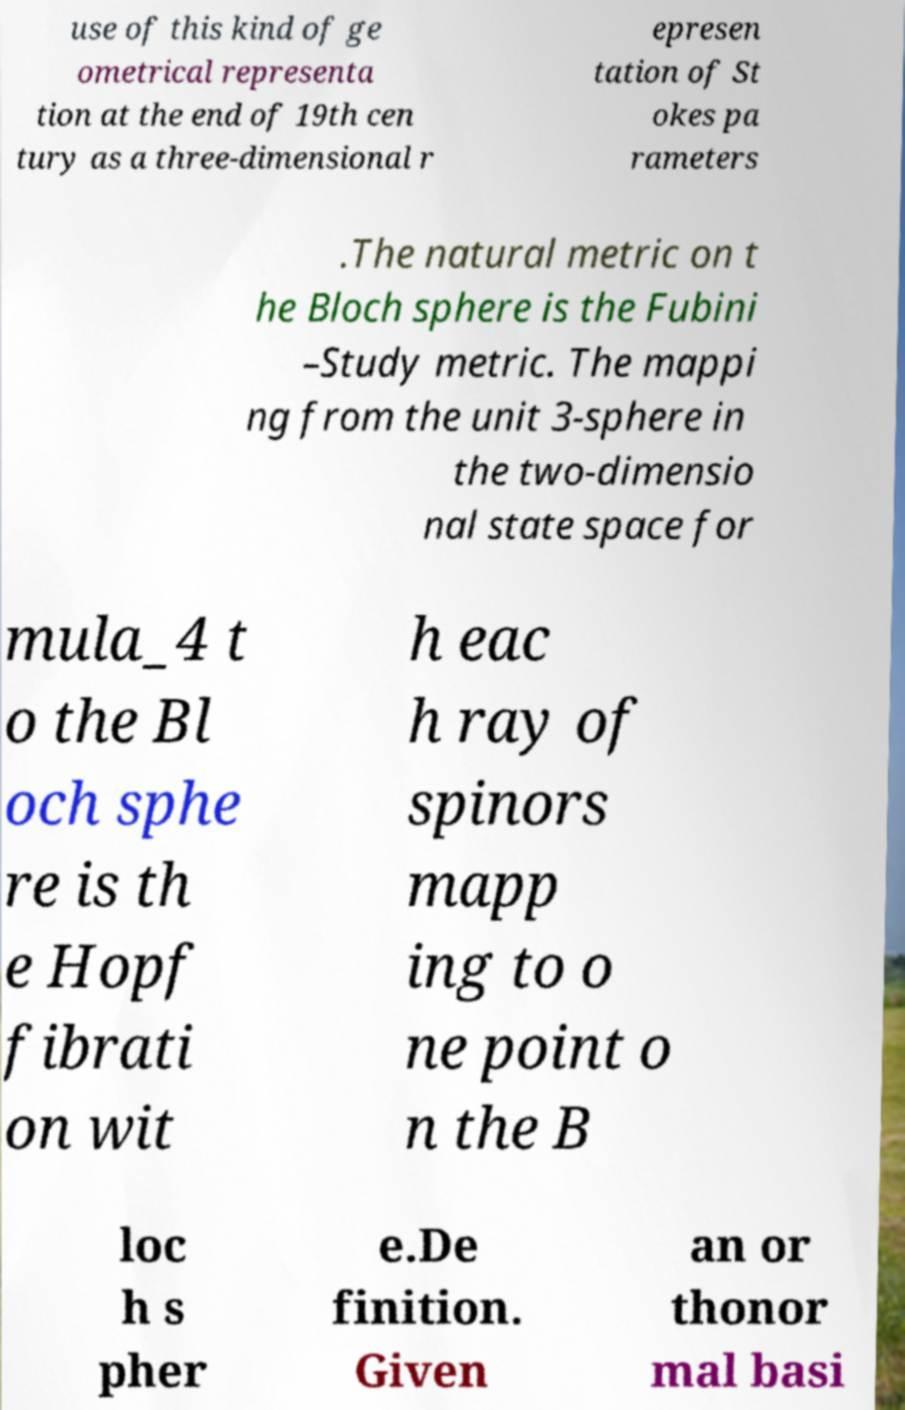For documentation purposes, I need the text within this image transcribed. Could you provide that? use of this kind of ge ometrical representa tion at the end of 19th cen tury as a three-dimensional r epresen tation of St okes pa rameters .The natural metric on t he Bloch sphere is the Fubini –Study metric. The mappi ng from the unit 3-sphere in the two-dimensio nal state space for mula_4 t o the Bl och sphe re is th e Hopf fibrati on wit h eac h ray of spinors mapp ing to o ne point o n the B loc h s pher e.De finition. Given an or thonor mal basi 